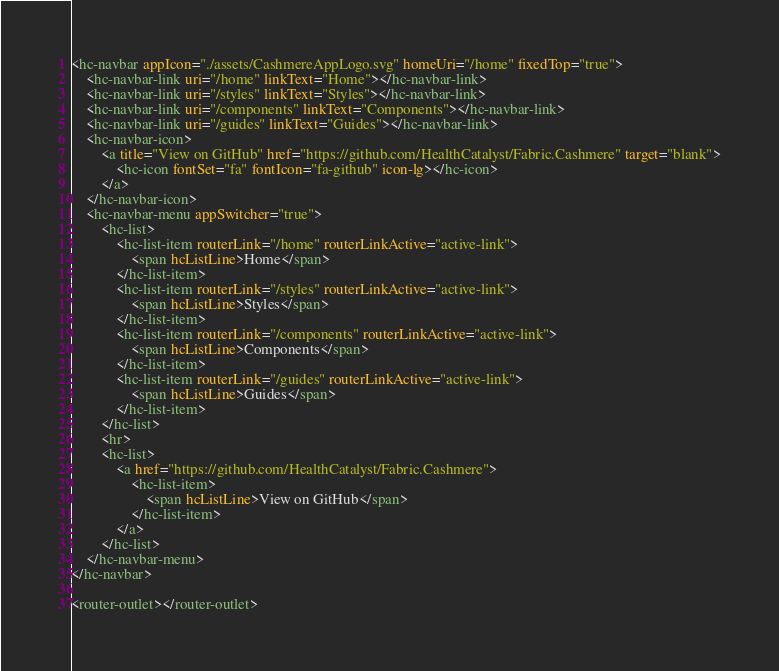<code> <loc_0><loc_0><loc_500><loc_500><_HTML_><hc-navbar appIcon="./assets/CashmereAppLogo.svg" homeUri="/home" fixedTop="true">
    <hc-navbar-link uri="/home" linkText="Home"></hc-navbar-link>
    <hc-navbar-link uri="/styles" linkText="Styles"></hc-navbar-link>
    <hc-navbar-link uri="/components" linkText="Components"></hc-navbar-link>
    <hc-navbar-link uri="/guides" linkText="Guides"></hc-navbar-link>
    <hc-navbar-icon>
        <a title="View on GitHub" href="https://github.com/HealthCatalyst/Fabric.Cashmere" target="blank">
            <hc-icon fontSet="fa" fontIcon="fa-github" icon-lg></hc-icon>
        </a>
    </hc-navbar-icon>
    <hc-navbar-menu appSwitcher="true">
        <hc-list>
            <hc-list-item routerLink="/home" routerLinkActive="active-link">
                <span hcListLine>Home</span>
            </hc-list-item>
            <hc-list-item routerLink="/styles" routerLinkActive="active-link">
                <span hcListLine>Styles</span>
            </hc-list-item>
            <hc-list-item routerLink="/components" routerLinkActive="active-link">
                <span hcListLine>Components</span>
            </hc-list-item>
            <hc-list-item routerLink="/guides" routerLinkActive="active-link">
                <span hcListLine>Guides</span>
            </hc-list-item>
        </hc-list>
        <hr>
        <hc-list>
            <a href="https://github.com/HealthCatalyst/Fabric.Cashmere">
                <hc-list-item>
                    <span hcListLine>View on GitHub</span>
                </hc-list-item>
            </a>
        </hc-list>
    </hc-navbar-menu>
</hc-navbar>

<router-outlet></router-outlet>
</code> 